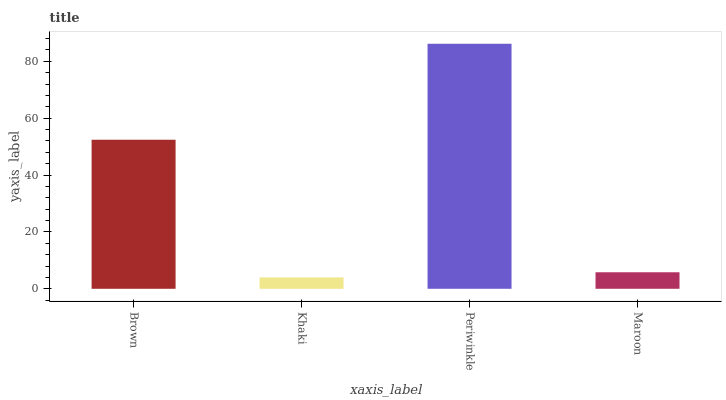Is Khaki the minimum?
Answer yes or no. Yes. Is Periwinkle the maximum?
Answer yes or no. Yes. Is Periwinkle the minimum?
Answer yes or no. No. Is Khaki the maximum?
Answer yes or no. No. Is Periwinkle greater than Khaki?
Answer yes or no. Yes. Is Khaki less than Periwinkle?
Answer yes or no. Yes. Is Khaki greater than Periwinkle?
Answer yes or no. No. Is Periwinkle less than Khaki?
Answer yes or no. No. Is Brown the high median?
Answer yes or no. Yes. Is Maroon the low median?
Answer yes or no. Yes. Is Khaki the high median?
Answer yes or no. No. Is Brown the low median?
Answer yes or no. No. 